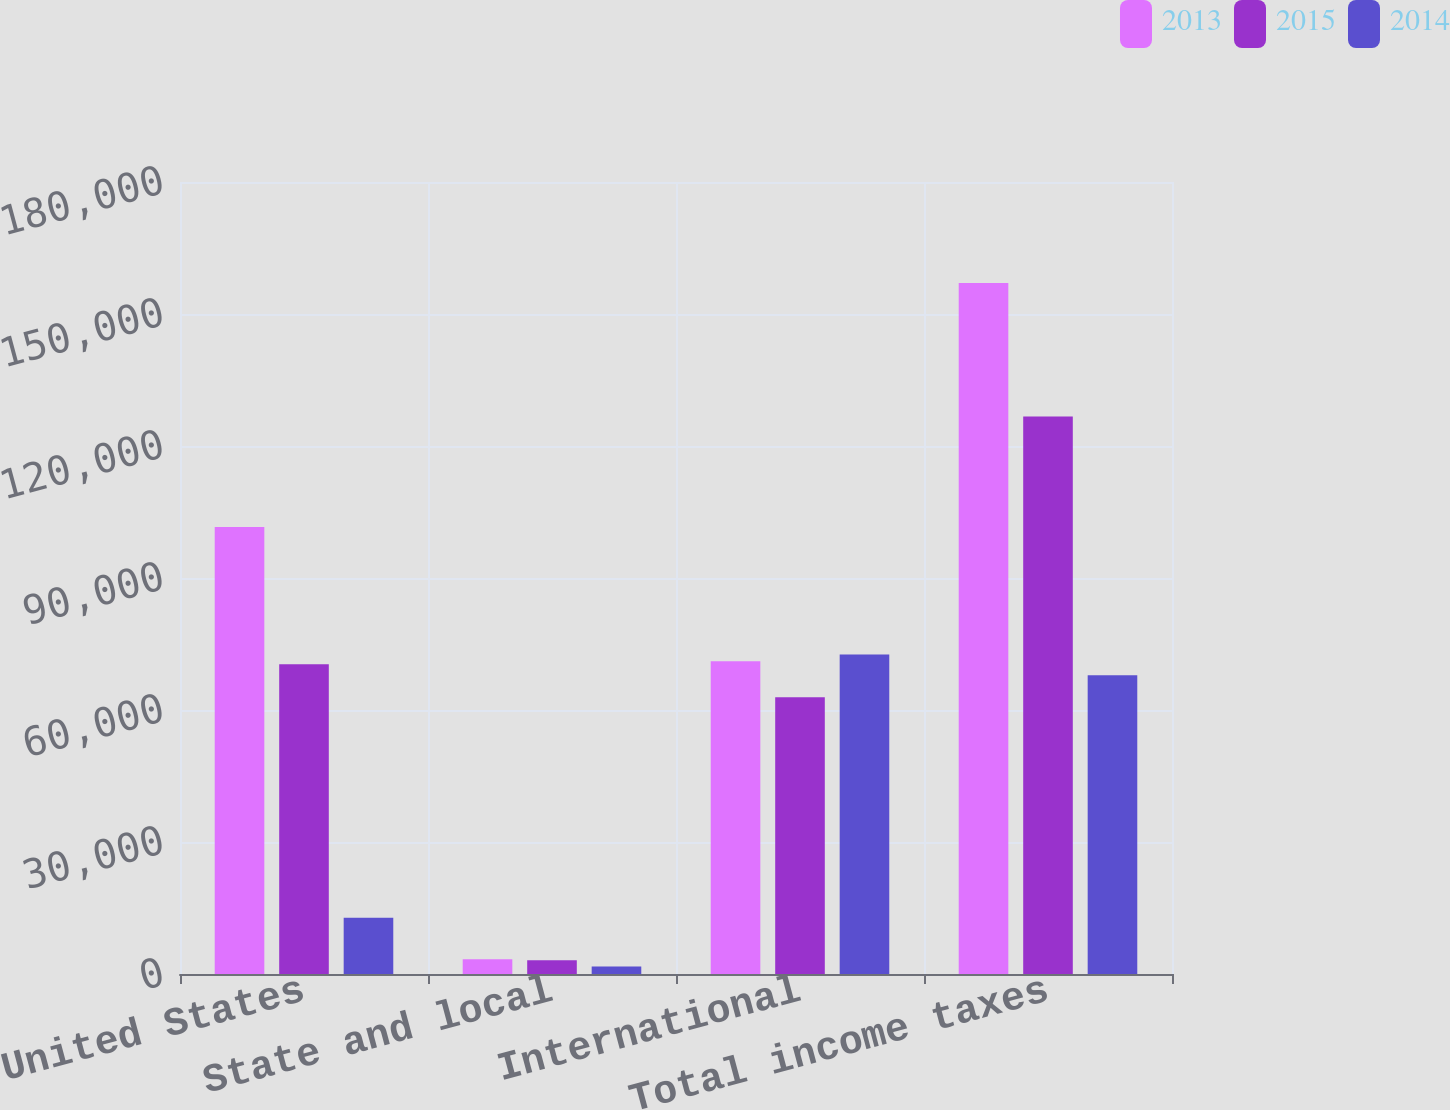<chart> <loc_0><loc_0><loc_500><loc_500><stacked_bar_chart><ecel><fcel>United States<fcel>State and local<fcel>International<fcel>Total income taxes<nl><fcel>2013<fcel>101591<fcel>3352<fcel>71054<fcel>157043<nl><fcel>2015<fcel>70390<fcel>3134<fcel>62909<fcel>126678<nl><fcel>2014<fcel>12760<fcel>1677<fcel>72640<fcel>67894<nl></chart> 